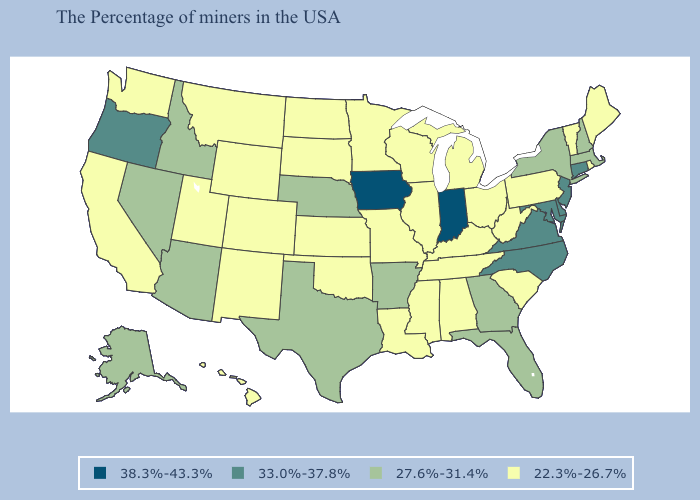Name the states that have a value in the range 38.3%-43.3%?
Answer briefly. Indiana, Iowa. Does Maryland have the lowest value in the USA?
Answer briefly. No. Name the states that have a value in the range 22.3%-26.7%?
Answer briefly. Maine, Rhode Island, Vermont, Pennsylvania, South Carolina, West Virginia, Ohio, Michigan, Kentucky, Alabama, Tennessee, Wisconsin, Illinois, Mississippi, Louisiana, Missouri, Minnesota, Kansas, Oklahoma, South Dakota, North Dakota, Wyoming, Colorado, New Mexico, Utah, Montana, California, Washington, Hawaii. What is the highest value in the USA?
Concise answer only. 38.3%-43.3%. Does Nebraska have the lowest value in the MidWest?
Short answer required. No. Does West Virginia have the same value as Virginia?
Short answer required. No. Among the states that border Montana , does Idaho have the highest value?
Be succinct. Yes. Does the map have missing data?
Quick response, please. No. Name the states that have a value in the range 22.3%-26.7%?
Be succinct. Maine, Rhode Island, Vermont, Pennsylvania, South Carolina, West Virginia, Ohio, Michigan, Kentucky, Alabama, Tennessee, Wisconsin, Illinois, Mississippi, Louisiana, Missouri, Minnesota, Kansas, Oklahoma, South Dakota, North Dakota, Wyoming, Colorado, New Mexico, Utah, Montana, California, Washington, Hawaii. What is the value of Arkansas?
Give a very brief answer. 27.6%-31.4%. What is the highest value in the West ?
Write a very short answer. 33.0%-37.8%. What is the lowest value in the USA?
Concise answer only. 22.3%-26.7%. Does Indiana have the lowest value in the MidWest?
Give a very brief answer. No. What is the value of North Dakota?
Be succinct. 22.3%-26.7%. Name the states that have a value in the range 22.3%-26.7%?
Keep it brief. Maine, Rhode Island, Vermont, Pennsylvania, South Carolina, West Virginia, Ohio, Michigan, Kentucky, Alabama, Tennessee, Wisconsin, Illinois, Mississippi, Louisiana, Missouri, Minnesota, Kansas, Oklahoma, South Dakota, North Dakota, Wyoming, Colorado, New Mexico, Utah, Montana, California, Washington, Hawaii. 